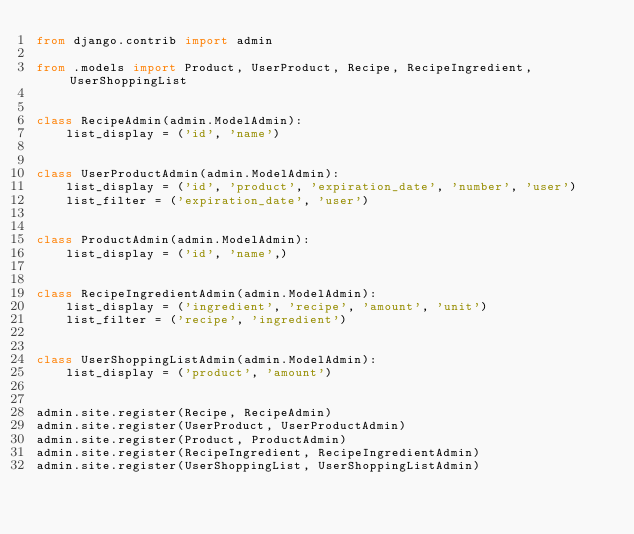<code> <loc_0><loc_0><loc_500><loc_500><_Python_>from django.contrib import admin

from .models import Product, UserProduct, Recipe, RecipeIngredient, UserShoppingList


class RecipeAdmin(admin.ModelAdmin):
    list_display = ('id', 'name')


class UserProductAdmin(admin.ModelAdmin):
    list_display = ('id', 'product', 'expiration_date', 'number', 'user')
    list_filter = ('expiration_date', 'user')


class ProductAdmin(admin.ModelAdmin):
    list_display = ('id', 'name',)


class RecipeIngredientAdmin(admin.ModelAdmin):
    list_display = ('ingredient', 'recipe', 'amount', 'unit')
    list_filter = ('recipe', 'ingredient')


class UserShoppingListAdmin(admin.ModelAdmin):
    list_display = ('product', 'amount')


admin.site.register(Recipe, RecipeAdmin)
admin.site.register(UserProduct, UserProductAdmin)
admin.site.register(Product, ProductAdmin)
admin.site.register(RecipeIngredient, RecipeIngredientAdmin)
admin.site.register(UserShoppingList, UserShoppingListAdmin)
</code> 